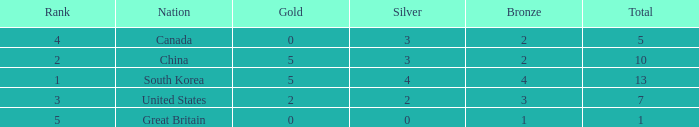What is Nation, when Rank is greater than 2, when Total is greater than 1, and when Bronze is less than 3? Canada. Could you help me parse every detail presented in this table? {'header': ['Rank', 'Nation', 'Gold', 'Silver', 'Bronze', 'Total'], 'rows': [['4', 'Canada', '0', '3', '2', '5'], ['2', 'China', '5', '3', '2', '10'], ['1', 'South Korea', '5', '4', '4', '13'], ['3', 'United States', '2', '2', '3', '7'], ['5', 'Great Britain', '0', '0', '1', '1']]} 